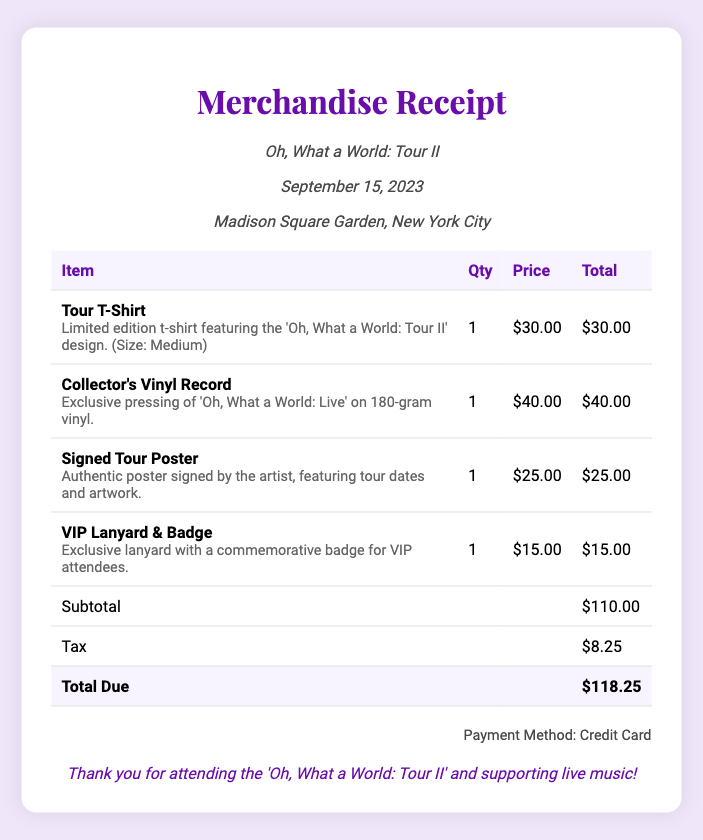What is the total amount due? The total amount is mentioned at the bottom of the receipt and is the final sum after tax.
Answer: $118.25 What date was the concert? The date of the concert is stated in the concert information section of the receipt.
Answer: September 15, 2023 How many items were purchased? Each line item in the receipt corresponds to one item purchased. Adding them gives the total number of items.
Answer: 4 What was the price of the Collector's Vinyl Record? The price of the Collector's Vinyl Record is clearly listed in the receipt table.
Answer: $40.00 What payment method was used? The payment method is specified near the bottom of the receipt.
Answer: Credit Card What is the description of the Signed Tour Poster? The description for the Signed Tour Poster is provided with the item in the receipt.
Answer: Authentic poster signed by the artist, featuring tour dates and artwork How much was the tax applied? The tax amount is mentioned in the receipt, providing clarity on the amount added to the subtotal.
Answer: $8.25 What size is the Tour T-Shirt? The size of the Tour T-Shirt is included within the item description in the receipt.
Answer: Medium 